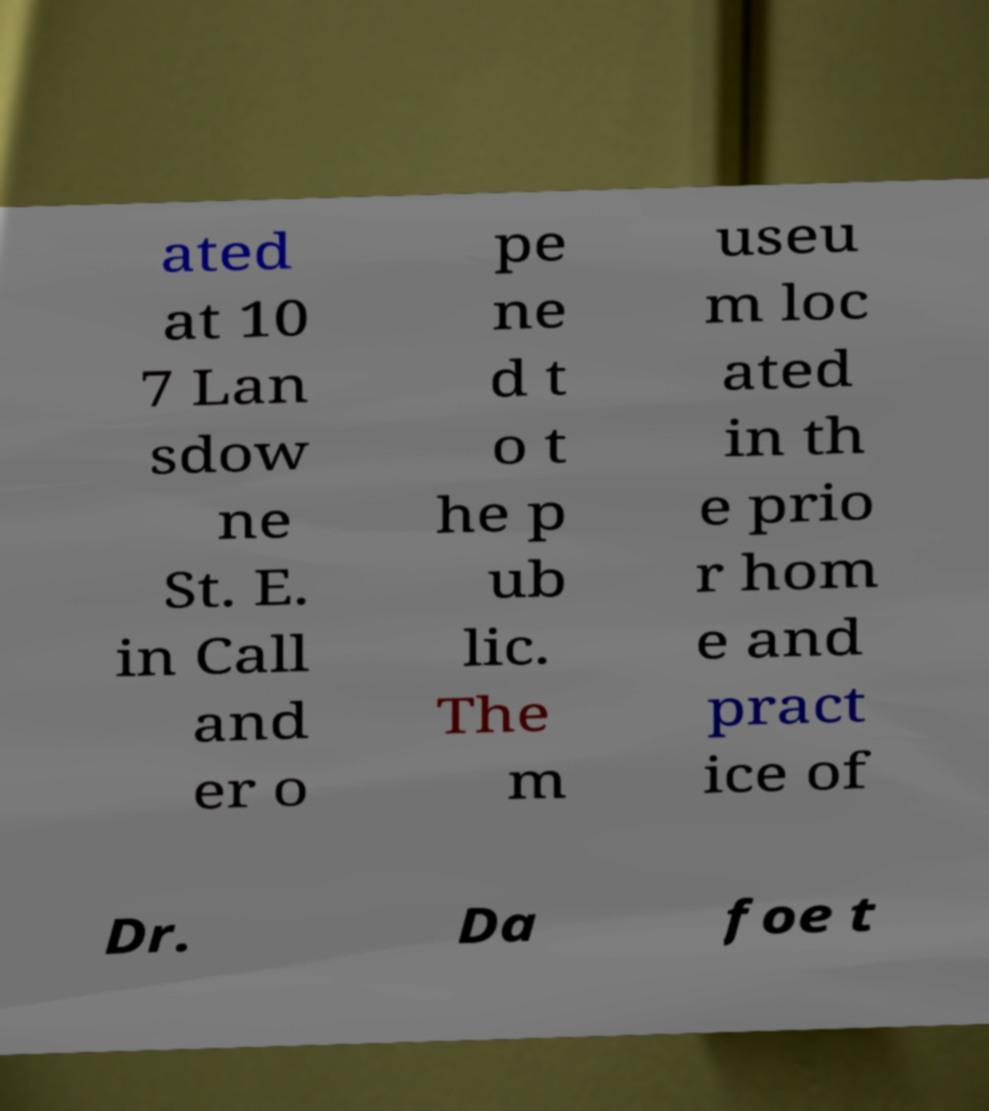Can you accurately transcribe the text from the provided image for me? ated at 10 7 Lan sdow ne St. E. in Call and er o pe ne d t o t he p ub lic. The m useu m loc ated in th e prio r hom e and pract ice of Dr. Da foe t 